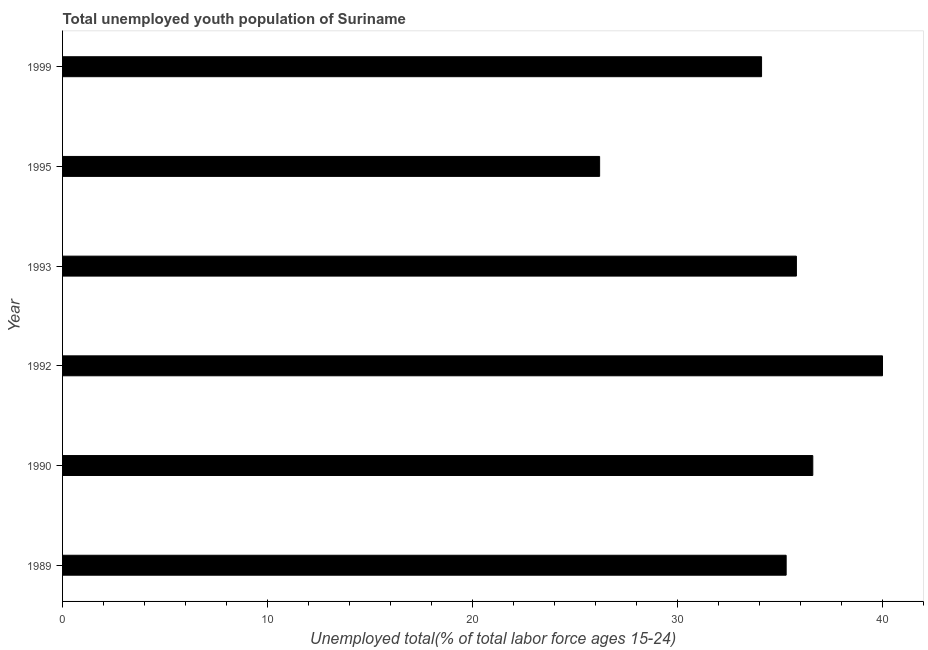What is the title of the graph?
Give a very brief answer. Total unemployed youth population of Suriname. What is the label or title of the X-axis?
Your answer should be compact. Unemployed total(% of total labor force ages 15-24). What is the unemployed youth in 1999?
Provide a short and direct response. 34.1. Across all years, what is the minimum unemployed youth?
Your response must be concise. 26.2. What is the sum of the unemployed youth?
Ensure brevity in your answer.  208. What is the average unemployed youth per year?
Offer a very short reply. 34.67. What is the median unemployed youth?
Your response must be concise. 35.55. Is the unemployed youth in 1989 less than that in 1999?
Your answer should be very brief. No. In how many years, is the unemployed youth greater than the average unemployed youth taken over all years?
Provide a succinct answer. 4. How many bars are there?
Ensure brevity in your answer.  6. Are all the bars in the graph horizontal?
Keep it short and to the point. Yes. What is the difference between two consecutive major ticks on the X-axis?
Ensure brevity in your answer.  10. Are the values on the major ticks of X-axis written in scientific E-notation?
Ensure brevity in your answer.  No. What is the Unemployed total(% of total labor force ages 15-24) of 1989?
Your response must be concise. 35.3. What is the Unemployed total(% of total labor force ages 15-24) of 1990?
Keep it short and to the point. 36.6. What is the Unemployed total(% of total labor force ages 15-24) of 1992?
Offer a terse response. 40. What is the Unemployed total(% of total labor force ages 15-24) in 1993?
Provide a short and direct response. 35.8. What is the Unemployed total(% of total labor force ages 15-24) in 1995?
Ensure brevity in your answer.  26.2. What is the Unemployed total(% of total labor force ages 15-24) of 1999?
Ensure brevity in your answer.  34.1. What is the difference between the Unemployed total(% of total labor force ages 15-24) in 1989 and 1990?
Your answer should be compact. -1.3. What is the difference between the Unemployed total(% of total labor force ages 15-24) in 1989 and 1992?
Give a very brief answer. -4.7. What is the difference between the Unemployed total(% of total labor force ages 15-24) in 1989 and 1995?
Provide a short and direct response. 9.1. What is the difference between the Unemployed total(% of total labor force ages 15-24) in 1989 and 1999?
Make the answer very short. 1.2. What is the difference between the Unemployed total(% of total labor force ages 15-24) in 1990 and 1992?
Make the answer very short. -3.4. What is the difference between the Unemployed total(% of total labor force ages 15-24) in 1990 and 1993?
Provide a short and direct response. 0.8. What is the difference between the Unemployed total(% of total labor force ages 15-24) in 1990 and 1999?
Give a very brief answer. 2.5. What is the difference between the Unemployed total(% of total labor force ages 15-24) in 1993 and 1999?
Give a very brief answer. 1.7. What is the difference between the Unemployed total(% of total labor force ages 15-24) in 1995 and 1999?
Provide a succinct answer. -7.9. What is the ratio of the Unemployed total(% of total labor force ages 15-24) in 1989 to that in 1990?
Your answer should be very brief. 0.96. What is the ratio of the Unemployed total(% of total labor force ages 15-24) in 1989 to that in 1992?
Your answer should be compact. 0.88. What is the ratio of the Unemployed total(% of total labor force ages 15-24) in 1989 to that in 1995?
Make the answer very short. 1.35. What is the ratio of the Unemployed total(% of total labor force ages 15-24) in 1989 to that in 1999?
Make the answer very short. 1.03. What is the ratio of the Unemployed total(% of total labor force ages 15-24) in 1990 to that in 1992?
Make the answer very short. 0.92. What is the ratio of the Unemployed total(% of total labor force ages 15-24) in 1990 to that in 1993?
Give a very brief answer. 1.02. What is the ratio of the Unemployed total(% of total labor force ages 15-24) in 1990 to that in 1995?
Make the answer very short. 1.4. What is the ratio of the Unemployed total(% of total labor force ages 15-24) in 1990 to that in 1999?
Give a very brief answer. 1.07. What is the ratio of the Unemployed total(% of total labor force ages 15-24) in 1992 to that in 1993?
Offer a terse response. 1.12. What is the ratio of the Unemployed total(% of total labor force ages 15-24) in 1992 to that in 1995?
Offer a terse response. 1.53. What is the ratio of the Unemployed total(% of total labor force ages 15-24) in 1992 to that in 1999?
Your answer should be very brief. 1.17. What is the ratio of the Unemployed total(% of total labor force ages 15-24) in 1993 to that in 1995?
Provide a short and direct response. 1.37. What is the ratio of the Unemployed total(% of total labor force ages 15-24) in 1995 to that in 1999?
Offer a terse response. 0.77. 